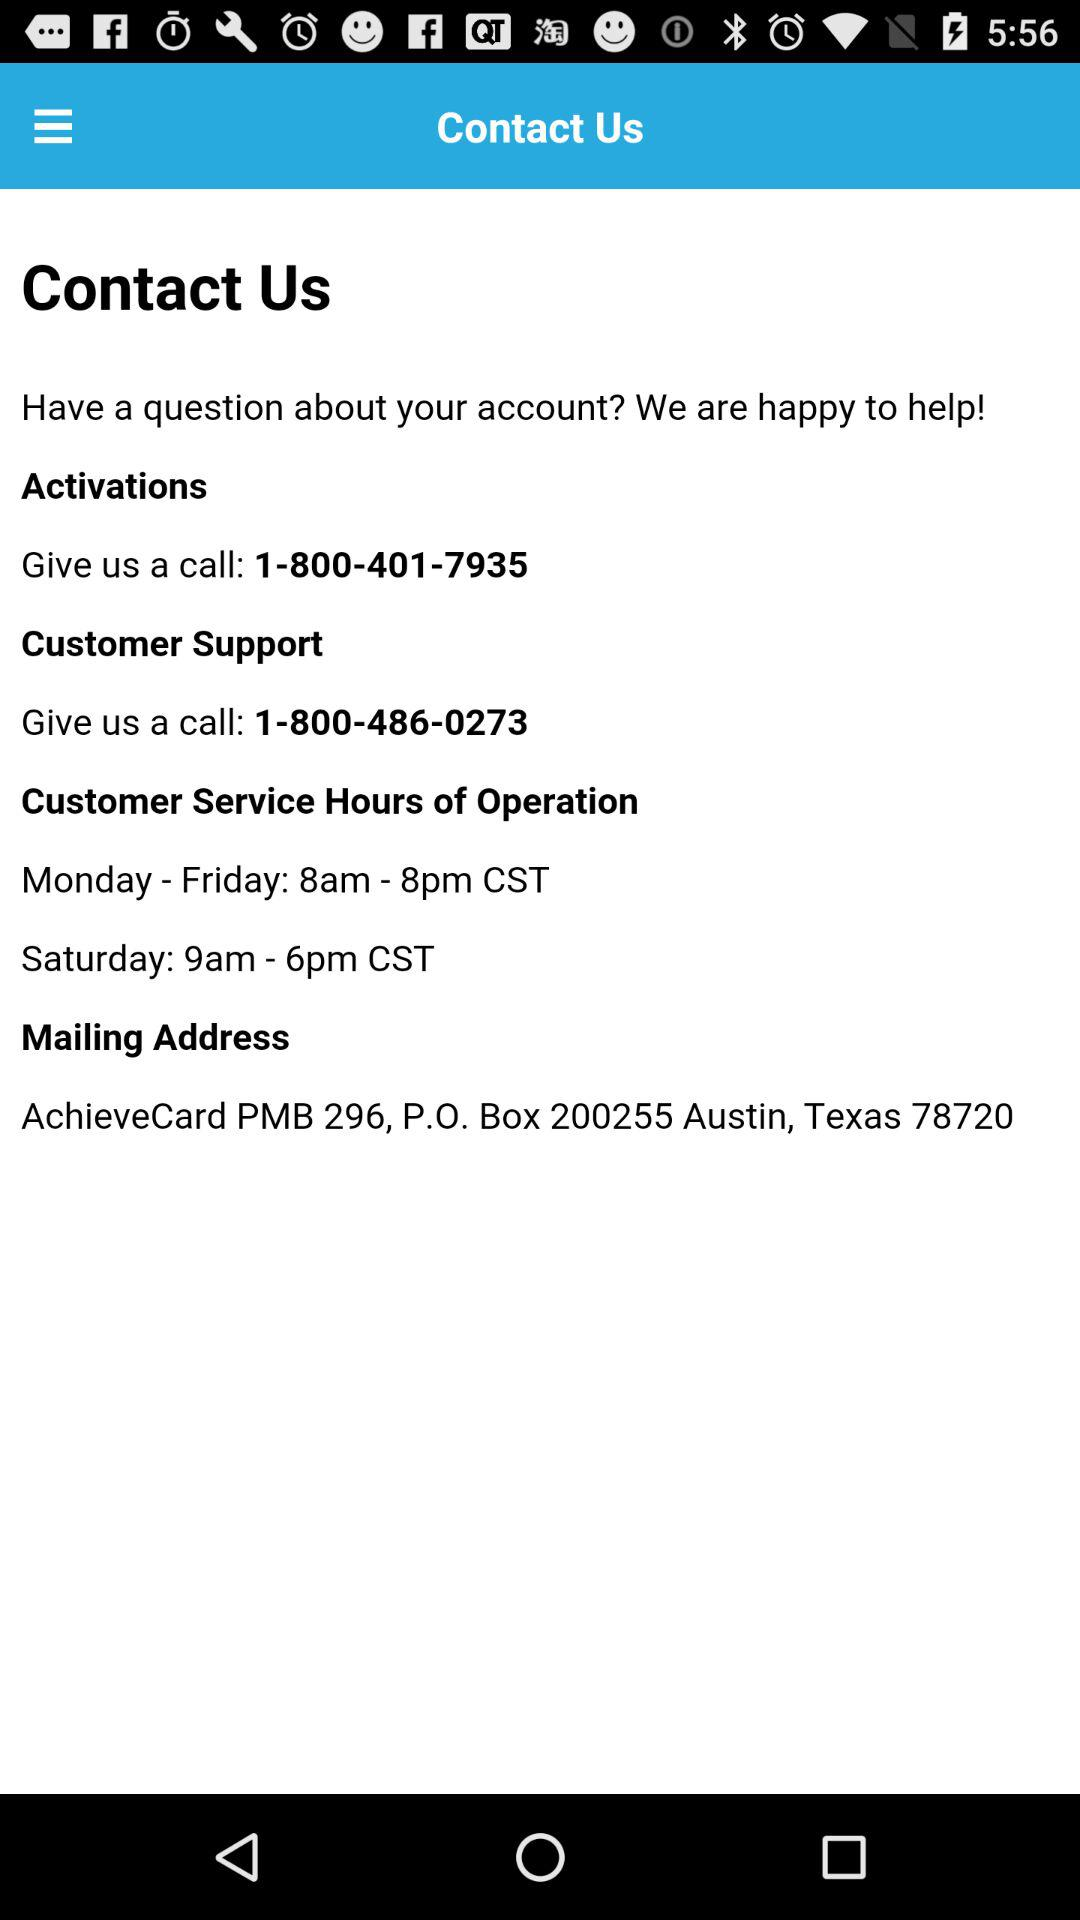What is the contact number for customer support? The contact number for customer support is 1-800-486-0273. 